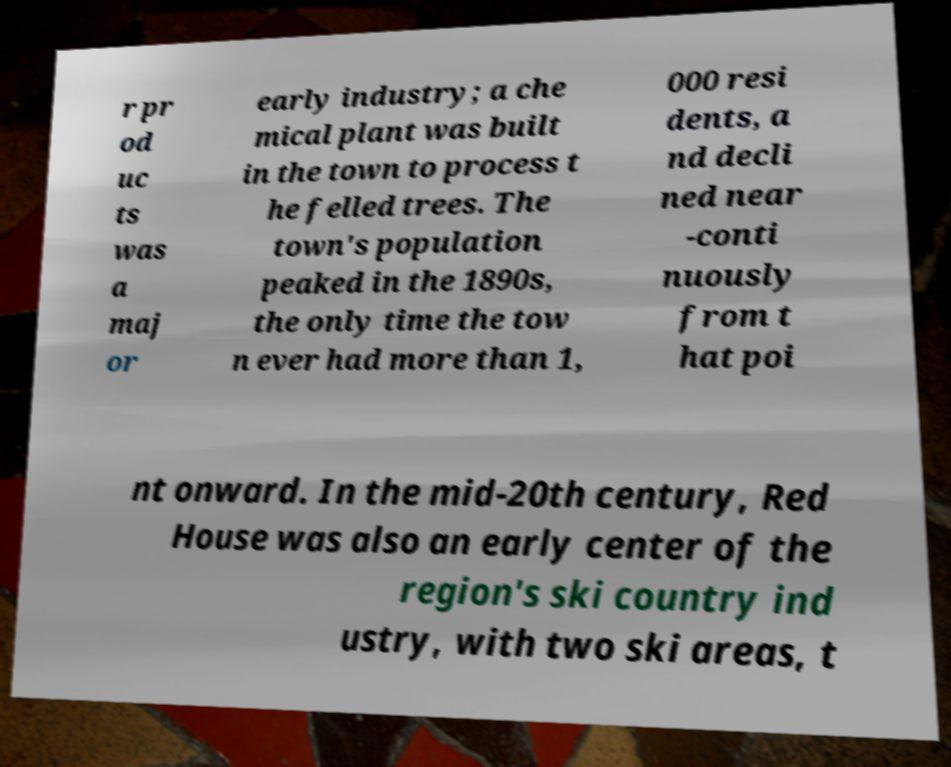I need the written content from this picture converted into text. Can you do that? r pr od uc ts was a maj or early industry; a che mical plant was built in the town to process t he felled trees. The town's population peaked in the 1890s, the only time the tow n ever had more than 1, 000 resi dents, a nd decli ned near -conti nuously from t hat poi nt onward. In the mid-20th century, Red House was also an early center of the region's ski country ind ustry, with two ski areas, t 